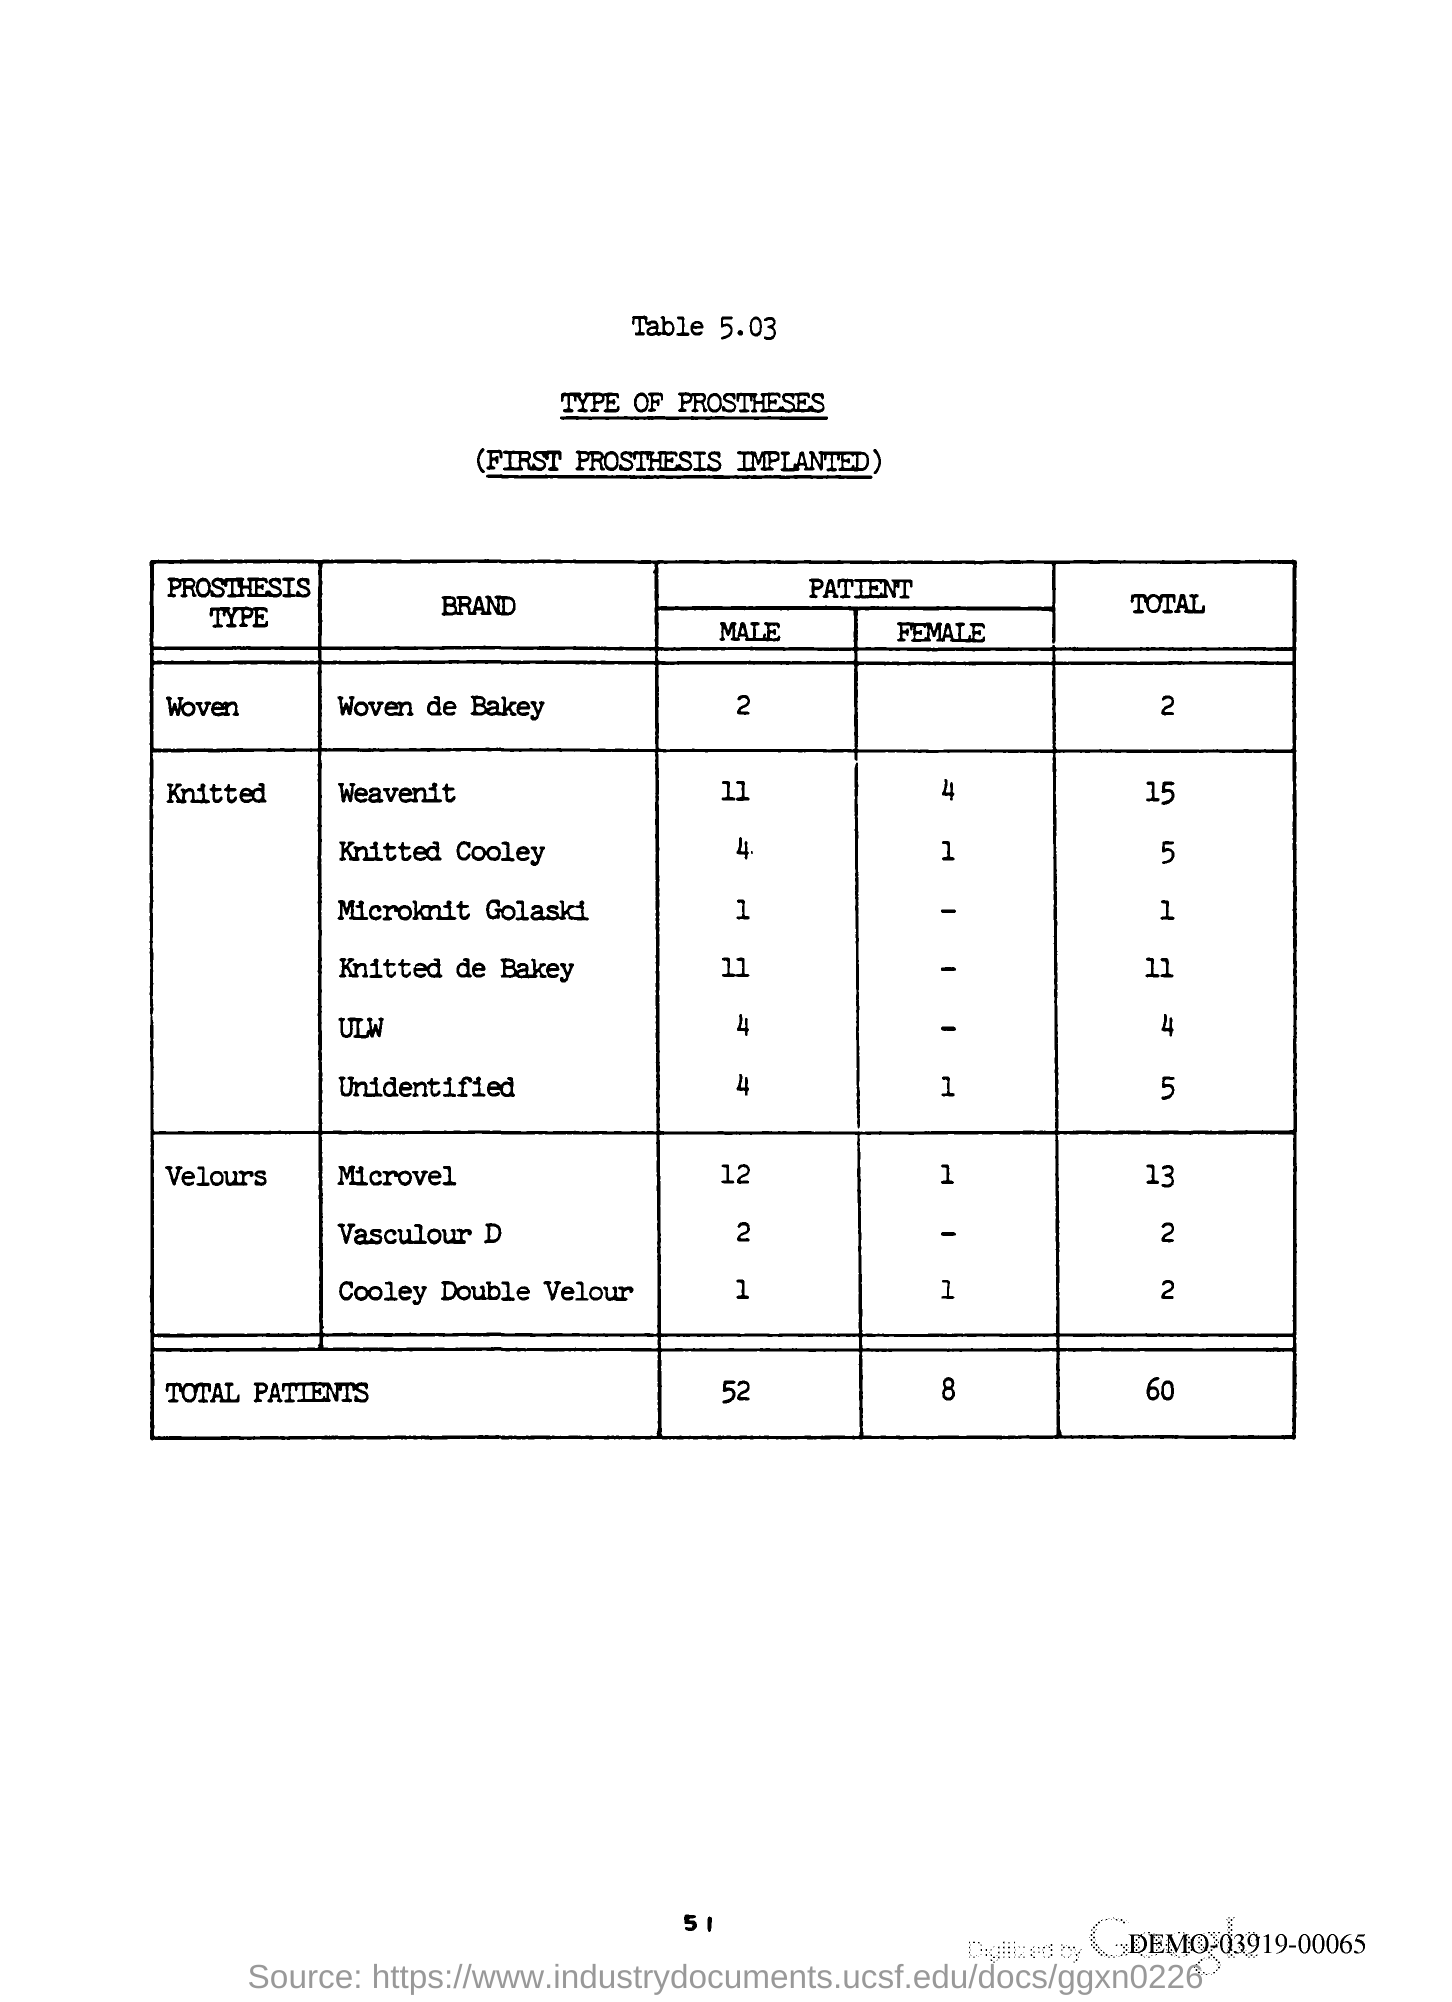Give some essential details in this illustration. The page number is 51. 